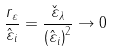Convert formula to latex. <formula><loc_0><loc_0><loc_500><loc_500>\frac { r _ { \varepsilon } } { \hat { \varepsilon } _ { i } } = \frac { \check { \varepsilon } _ { \lambda } } { \left ( \hat { \varepsilon } _ { i } \right ) ^ { 2 } } \rightarrow 0</formula> 